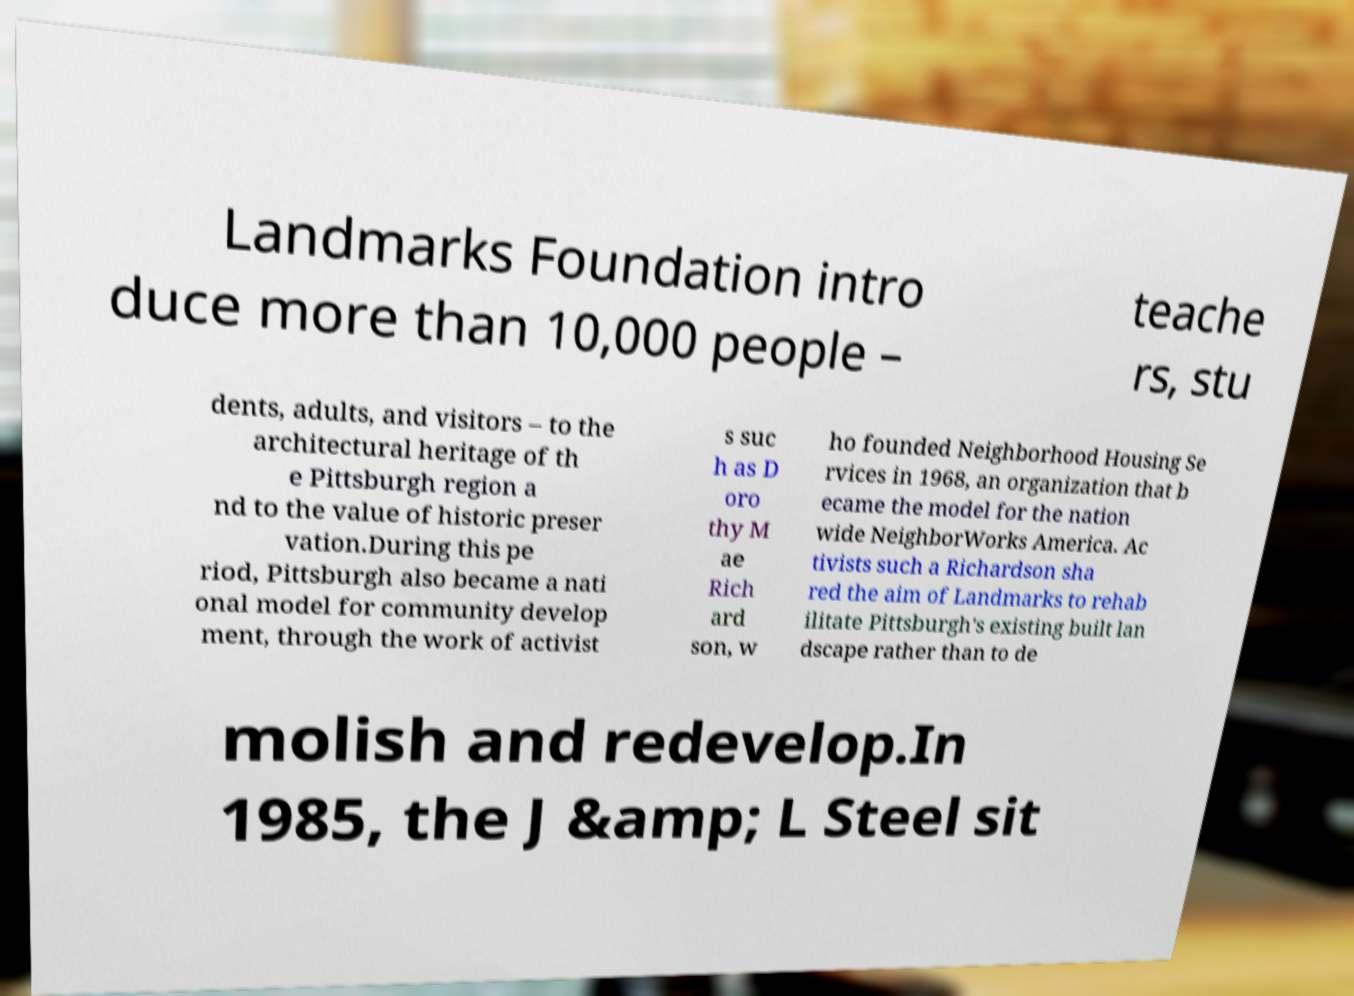Please read and relay the text visible in this image. What does it say? Landmarks Foundation intro duce more than 10,000 people – teache rs, stu dents, adults, and visitors – to the architectural heritage of th e Pittsburgh region a nd to the value of historic preser vation.During this pe riod, Pittsburgh also became a nati onal model for community develop ment, through the work of activist s suc h as D oro thy M ae Rich ard son, w ho founded Neighborhood Housing Se rvices in 1968, an organization that b ecame the model for the nation wide NeighborWorks America. Ac tivists such a Richardson sha red the aim of Landmarks to rehab ilitate Pittsburgh's existing built lan dscape rather than to de molish and redevelop.In 1985, the J &amp; L Steel sit 